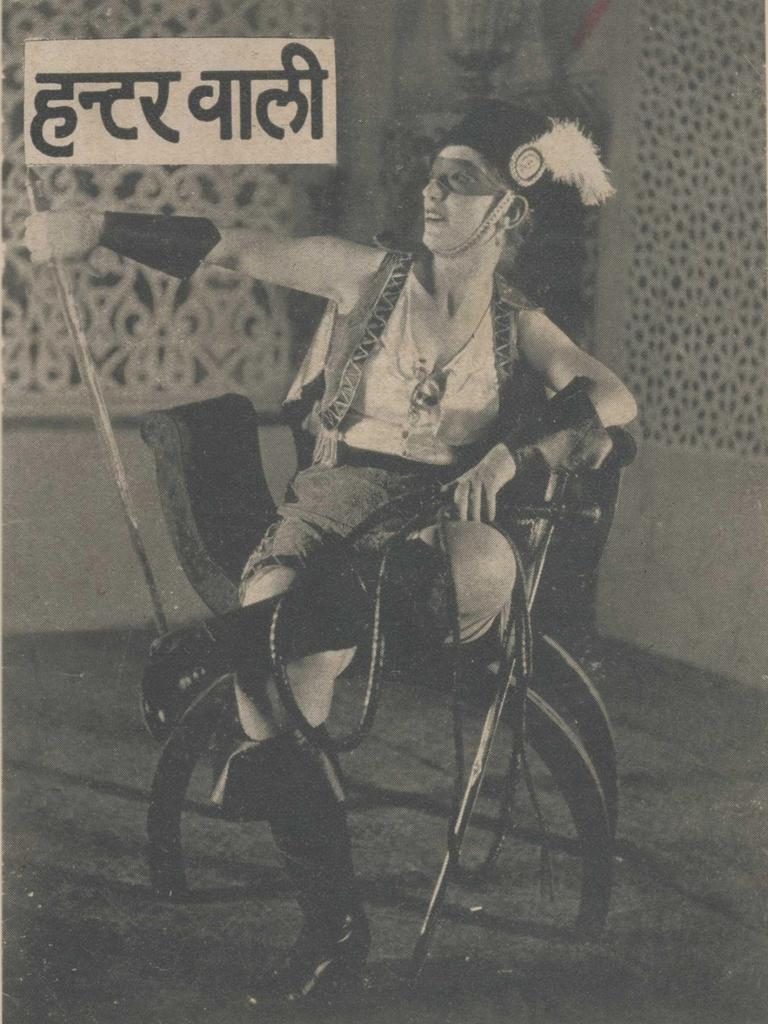What is the color scheme of the image? The image is black and white. What is the woman in the image doing? The woman is sitting in the image. What is the woman holding in her hand? The woman is holding a rope in her hand. What can be seen behind the woman? There is a wall behind the woman. Is there any text or logo visible in the image? Yes, there is a watermark at the top of the image. What type of toys can be seen on the floor in the image? There are no toys visible in the image; it features a woman sitting and holding a rope. Can you tell me how many times the woman drops the rope in the image? The image does not show the woman dropping the rope, so it cannot be determined from the image. 